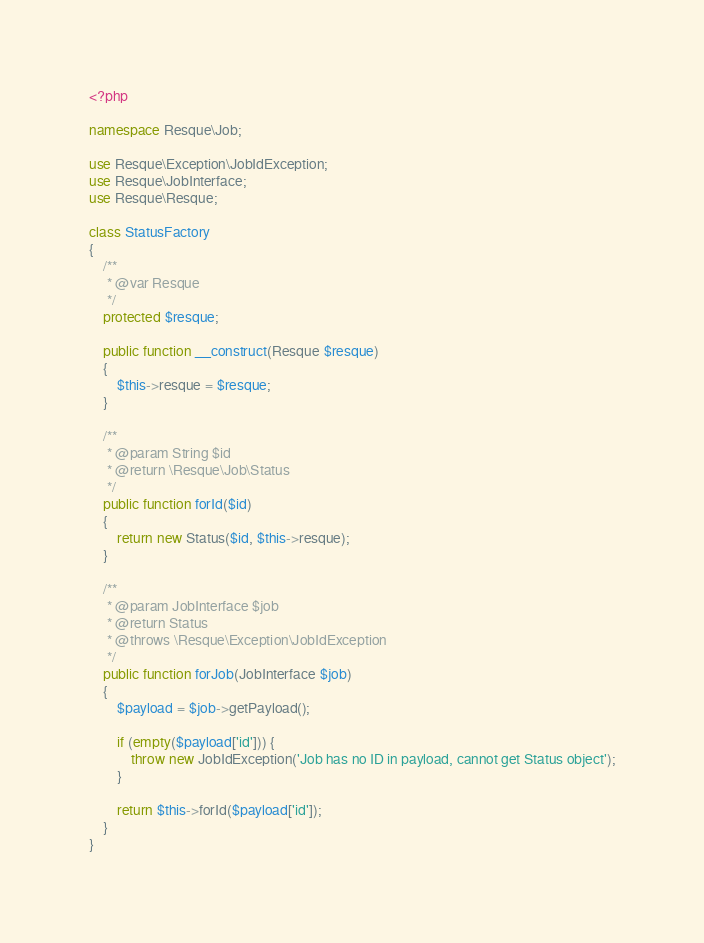<code> <loc_0><loc_0><loc_500><loc_500><_PHP_><?php

namespace Resque\Job;

use Resque\Exception\JobIdException;
use Resque\JobInterface;
use Resque\Resque;

class StatusFactory
{
    /**
     * @var Resque
     */
    protected $resque;

    public function __construct(Resque $resque)
    {
        $this->resque = $resque;
    }

    /**
     * @param String $id
     * @return \Resque\Job\Status
     */
    public function forId($id)
    {
        return new Status($id, $this->resque);
    }

    /**
     * @param JobInterface $job
     * @return Status
     * @throws \Resque\Exception\JobIdException
     */
    public function forJob(JobInterface $job)
    {
        $payload = $job->getPayload();

        if (empty($payload['id'])) {
            throw new JobIdException('Job has no ID in payload, cannot get Status object');
        }

        return $this->forId($payload['id']);
    }
}
</code> 